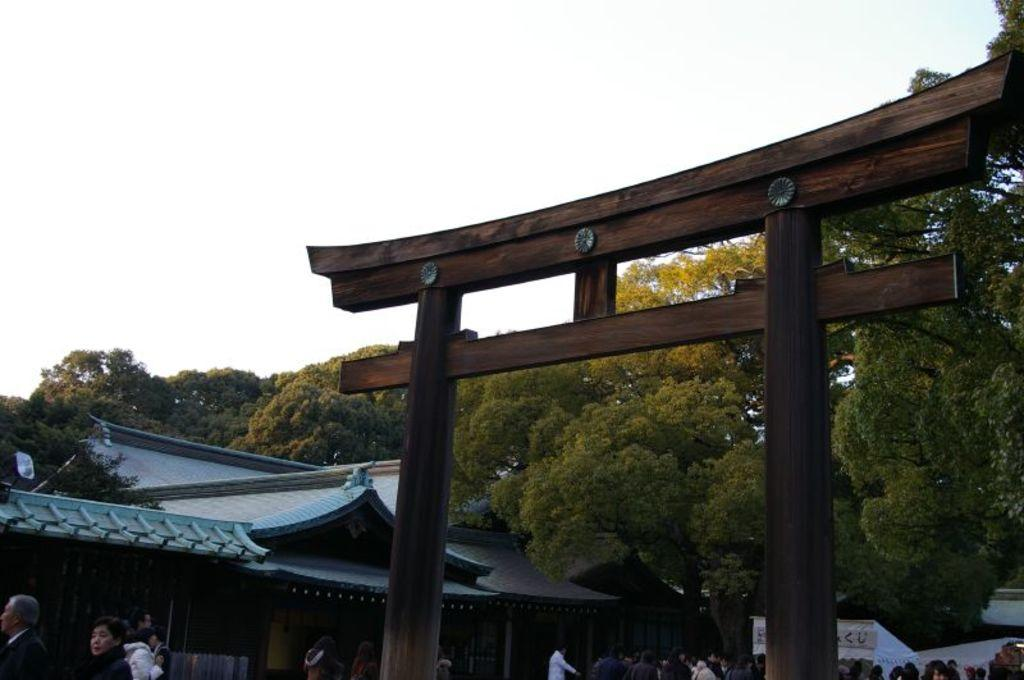What type of structures are present in the image? There are sheds and tents in the image. Are there any people in the image? Yes, there are people in the image. What can be seen in the background of the image? There is a wooden arch and trees in the background of the image. What type of lighting is visible in the image? There are lights visible in the image. What is visible at the top of the image? The sky is visible at the top of the image. What type of school can be seen in the image? There is no school present in the image. Is there any corn growing in the image? There is no corn visible in the image. 